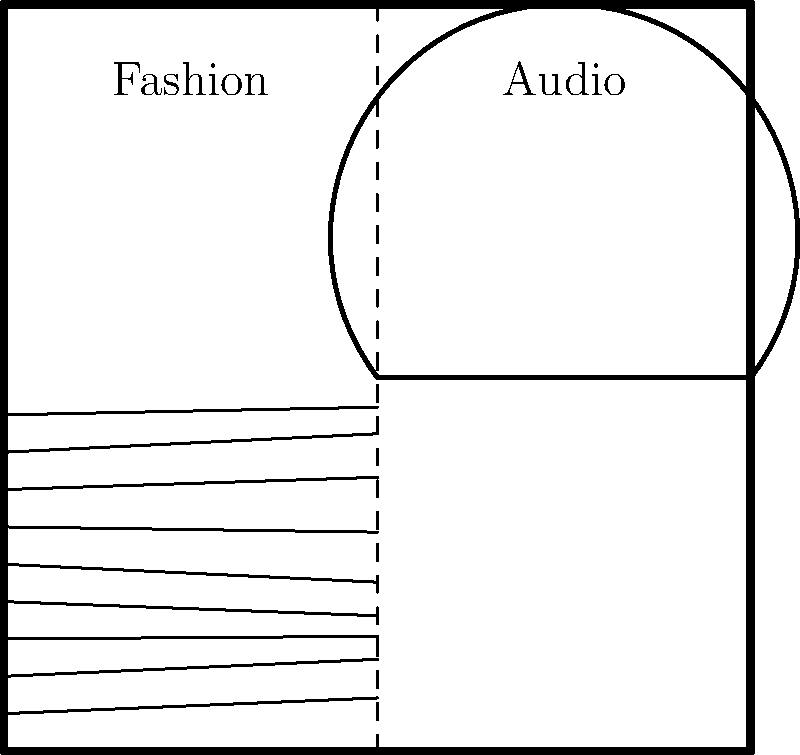In creating a mood board that combines fashion sketches and audio spectrograms for runway show inspiration, what is the optimal ratio of visual elements to audio elements to achieve a balanced and cohesive presentation? To determine the optimal ratio of visual elements (fashion sketches) to audio elements (spectrograms) in a mood board, we need to consider several factors:

1. Visual impact: Fashion sketches are typically more visually striking and immediately recognizable.
2. Complexity: Audio spectrograms can be more abstract and require more cognitive processing.
3. Complementary nature: The goal is to create a harmonious blend that inspires both visual and auditory creativity.
4. Industry standard: In fashion, visuals often take precedence, but audio is crucial for runway shows.
5. Information density: Spectrograms can convey a lot of information in a small space.

Considering these factors, a balanced approach would be to use a slightly higher proportion of fashion sketches to audio spectrograms. This ensures the mood board remains visually appealing while incorporating the important audio elements.

A common ratio used in design is the golden ratio, approximately 1.618:1. Adapting this for our purpose, we can use a simplified ratio of 3:2.

Therefore, the optimal ratio of visual elements (fashion sketches) to audio elements (spectrograms) would be 3:2 or 60% visual to 40% audio.
Answer: 3:2 ratio (60% visual, 40% audio) 